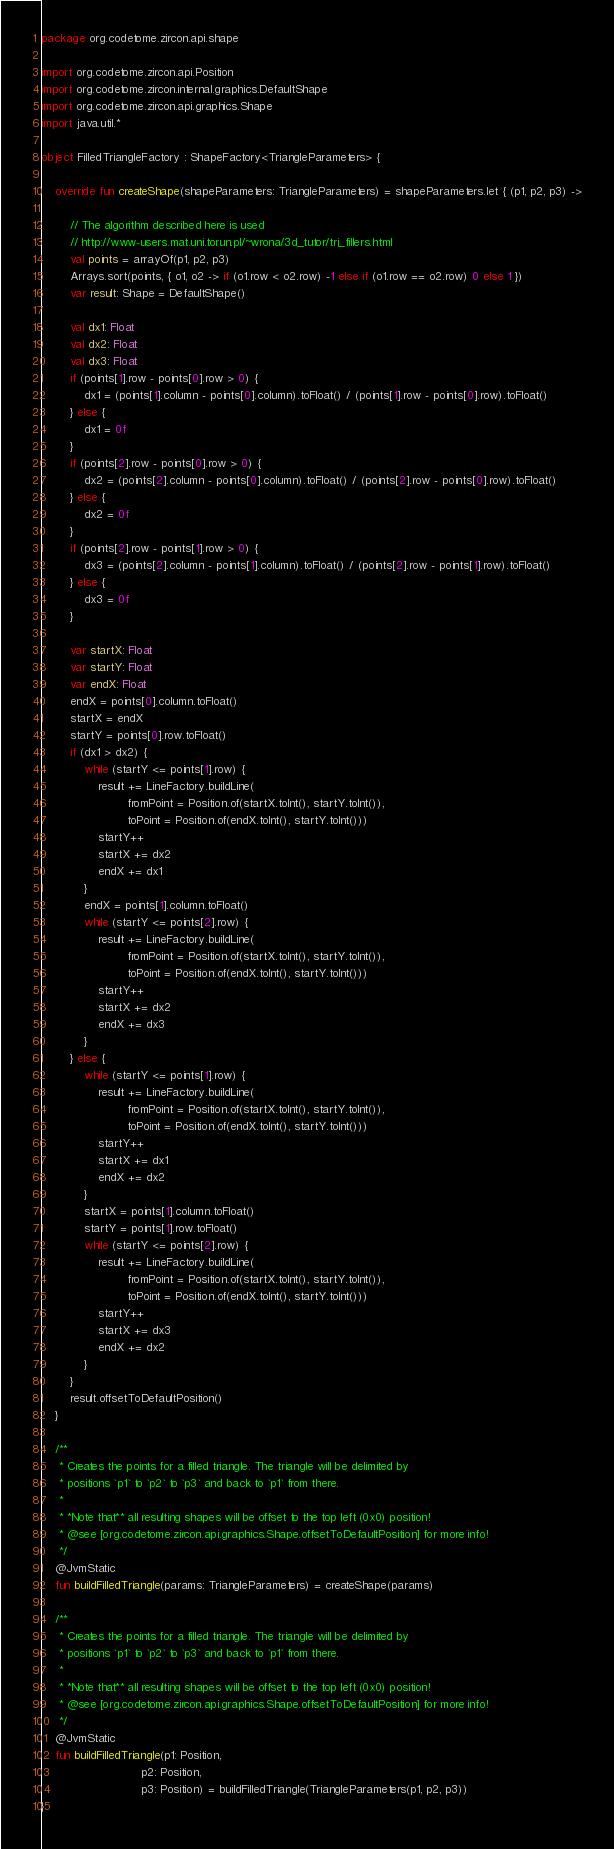Convert code to text. <code><loc_0><loc_0><loc_500><loc_500><_Kotlin_>package org.codetome.zircon.api.shape

import org.codetome.zircon.api.Position
import org.codetome.zircon.internal.graphics.DefaultShape
import org.codetome.zircon.api.graphics.Shape
import java.util.*

object FilledTriangleFactory : ShapeFactory<TriangleParameters> {

    override fun createShape(shapeParameters: TriangleParameters) = shapeParameters.let { (p1, p2, p3) ->

        // The algorithm described here is used
        // http://www-users.mat.uni.torun.pl/~wrona/3d_tutor/tri_fillers.html
        val points = arrayOf(p1, p2, p3)
        Arrays.sort(points, { o1, o2 -> if (o1.row < o2.row) -1 else if (o1.row == o2.row) 0 else 1 })
        var result: Shape = DefaultShape()

        val dx1: Float
        val dx2: Float
        val dx3: Float
        if (points[1].row - points[0].row > 0) {
            dx1 = (points[1].column - points[0].column).toFloat() / (points[1].row - points[0].row).toFloat()
        } else {
            dx1 = 0f
        }
        if (points[2].row - points[0].row > 0) {
            dx2 = (points[2].column - points[0].column).toFloat() / (points[2].row - points[0].row).toFloat()
        } else {
            dx2 = 0f
        }
        if (points[2].row - points[1].row > 0) {
            dx3 = (points[2].column - points[1].column).toFloat() / (points[2].row - points[1].row).toFloat()
        } else {
            dx3 = 0f
        }

        var startX: Float
        var startY: Float
        var endX: Float
        endX = points[0].column.toFloat()
        startX = endX
        startY = points[0].row.toFloat()
        if (dx1 > dx2) {
            while (startY <= points[1].row) {
                result += LineFactory.buildLine(
                        fromPoint = Position.of(startX.toInt(), startY.toInt()),
                        toPoint = Position.of(endX.toInt(), startY.toInt()))
                startY++
                startX += dx2
                endX += dx1
            }
            endX = points[1].column.toFloat()
            while (startY <= points[2].row) {
                result += LineFactory.buildLine(
                        fromPoint = Position.of(startX.toInt(), startY.toInt()),
                        toPoint = Position.of(endX.toInt(), startY.toInt()))
                startY++
                startX += dx2
                endX += dx3
            }
        } else {
            while (startY <= points[1].row) {
                result += LineFactory.buildLine(
                        fromPoint = Position.of(startX.toInt(), startY.toInt()),
                        toPoint = Position.of(endX.toInt(), startY.toInt()))
                startY++
                startX += dx1
                endX += dx2
            }
            startX = points[1].column.toFloat()
            startY = points[1].row.toFloat()
            while (startY <= points[2].row) {
                result += LineFactory.buildLine(
                        fromPoint = Position.of(startX.toInt(), startY.toInt()),
                        toPoint = Position.of(endX.toInt(), startY.toInt()))
                startY++
                startX += dx3
                endX += dx2
            }
        }
        result.offsetToDefaultPosition()
    }

    /**
     * Creates the points for a filled triangle. The triangle will be delimited by
     * positions `p1` to `p2` to `p3` and back to `p1` from there.
     *
     * *Note that** all resulting shapes will be offset to the top left (0x0) position!
     * @see [org.codetome.zircon.api.graphics.Shape.offsetToDefaultPosition] for more info!
     */
    @JvmStatic
    fun buildFilledTriangle(params: TriangleParameters) = createShape(params)

    /**
     * Creates the points for a filled triangle. The triangle will be delimited by
     * positions `p1` to `p2` to `p3` and back to `p1` from there.
     *
     * *Note that** all resulting shapes will be offset to the top left (0x0) position!
     * @see [org.codetome.zircon.api.graphics.Shape.offsetToDefaultPosition] for more info!
     */
    @JvmStatic
    fun buildFilledTriangle(p1: Position,
                            p2: Position,
                            p3: Position) = buildFilledTriangle(TriangleParameters(p1, p2, p3))
}</code> 